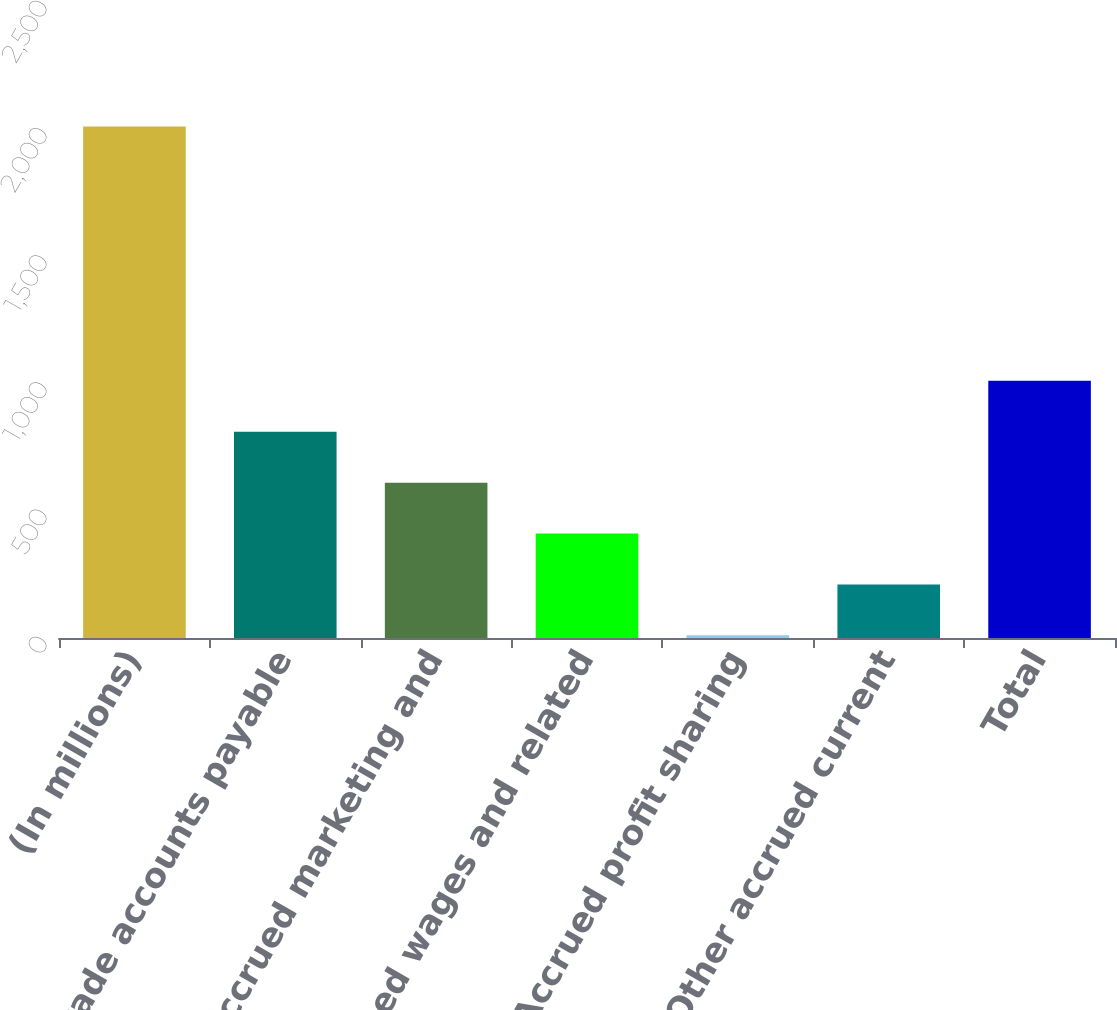Convert chart to OTSL. <chart><loc_0><loc_0><loc_500><loc_500><bar_chart><fcel>(In millions)<fcel>Trade accounts payable<fcel>Accrued marketing and<fcel>Accrued wages and related<fcel>Accrued profit sharing<fcel>Other accrued current<fcel>Total<nl><fcel>2011<fcel>810.7<fcel>610.65<fcel>410.6<fcel>10.5<fcel>210.55<fcel>1010.75<nl></chart> 